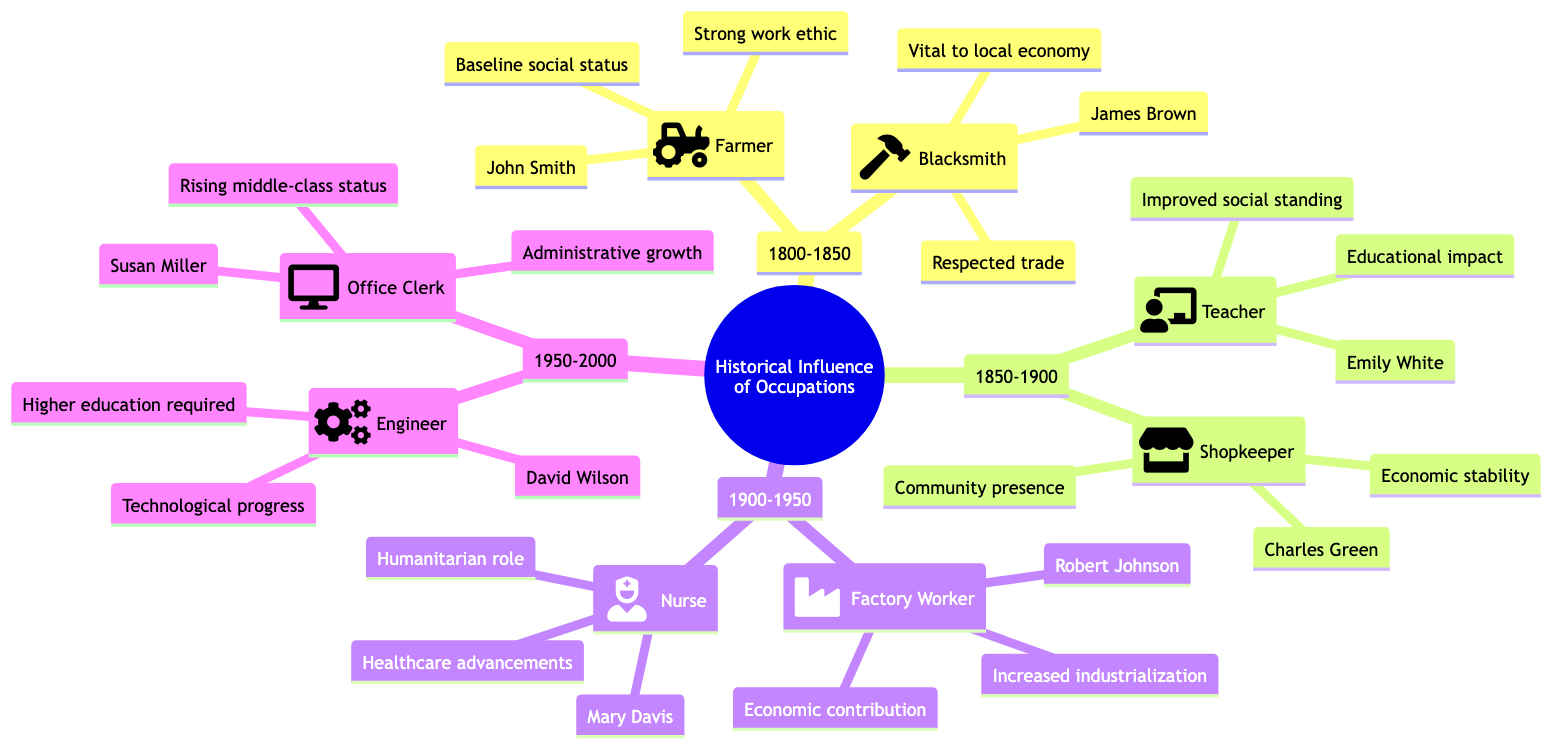What are the occupations in Generation 1? In Generation 1 (1800-1850), the occupations listed are Farmer and Blacksmith. We can identify these by looking at the nodes branching from 1800-1850 in the diagram.
Answer: Farmer, Blacksmith Who is a key figure for the occupation of Nurse? The key figure for the occupation of Nurse, which appears in Generation 3 (1900-1950), is Mary Davis. By examining the branches under the respective time period, we find her name associated with the Nurse occupation.
Answer: Mary Davis What is the influence of the Teacher occupation? The influence of the Teacher occupation, found in Generation 2 (1850-1900), is stated as improved social standing and educational impact. The diagram shows this information directly next to Teacher.
Answer: Improved social standing, educational impact How many key figures are identified for the occupation of Shopkeeper? There is one key figure identified for the occupation of Shopkeeper, which is Charles Green. Looking at the Shopkeeper node, we see only one name listed.
Answer: 1 Which occupation shows an influence related to technological progress? The occupation that shows an influence related to technological progress is Engineer, which is located in Generation 4 (1950-2000). The corresponding node contains the term "Technological progress."
Answer: Engineer What professions were present during the period 1900-1950? The professions present during the period 1900-1950 are Factory Worker and Nurse. We can identify these by looking at the nodes branching from the timeline of 1900 to 1950.
Answer: Factory Worker, Nurse What was the social status influence of the Office Clerk? The social status influence of the Office Clerk, appearing in Generation 4 (1950-2000), is rising middle-class status. This information is explicitly included in the description of the Office Clerk occupation.
Answer: Rising middle-class status Which generation had a Blacksmith as an occupation? The generation that had a Blacksmith as an occupation is Generation 1 (1800-1850). This can be verified by locating the Blacksmith node under the appropriate generation in the diagram.
Answer: Generation 1 What area did the Farmer occupation primarily occupy? The Farmer occupation primarily occupied rural areas, as indicated in the node details associated with the Farmer occupation in Generation 1 (1800-1850).
Answer: Rural areas 